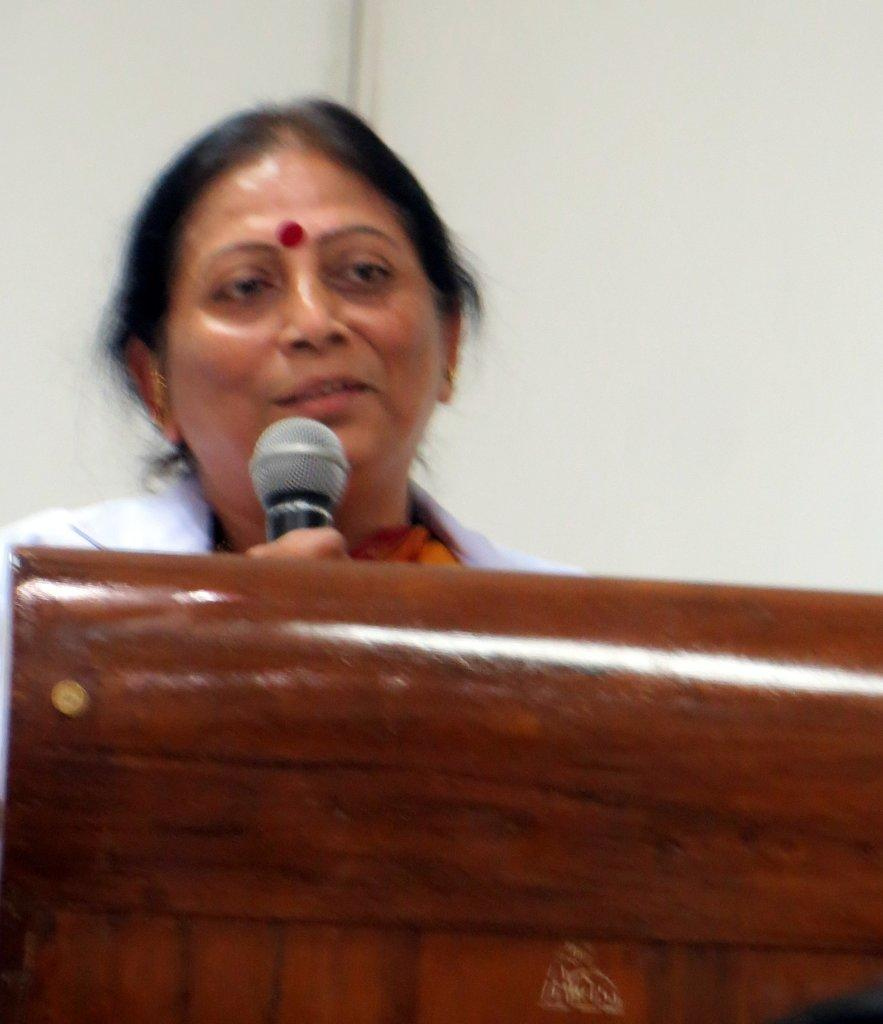What is the woman doing in the image? She is standing in front of a podium and holding a microphone. What is her facial expression in the image? She is smiling. What can be seen behind her in the image? There is a white color wall in the background. What type of friction is present between the woman and the podium in the image? There is no information about friction between the woman and the podium in the image. Can you see a tin object in the image? There is no tin object present in the image. 